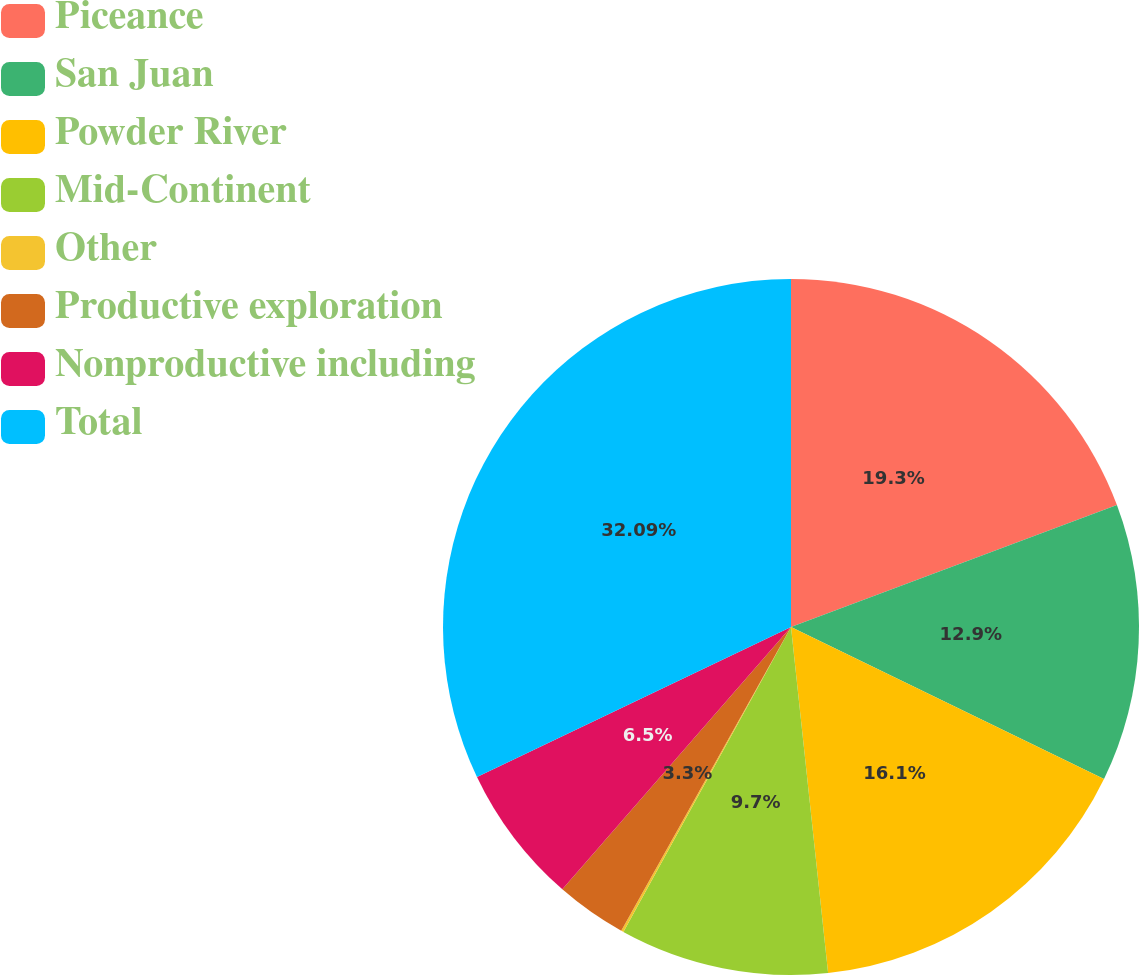<chart> <loc_0><loc_0><loc_500><loc_500><pie_chart><fcel>Piceance<fcel>San Juan<fcel>Powder River<fcel>Mid-Continent<fcel>Other<fcel>Productive exploration<fcel>Nonproductive including<fcel>Total<nl><fcel>19.3%<fcel>12.9%<fcel>16.1%<fcel>9.7%<fcel>0.11%<fcel>3.3%<fcel>6.5%<fcel>32.09%<nl></chart> 